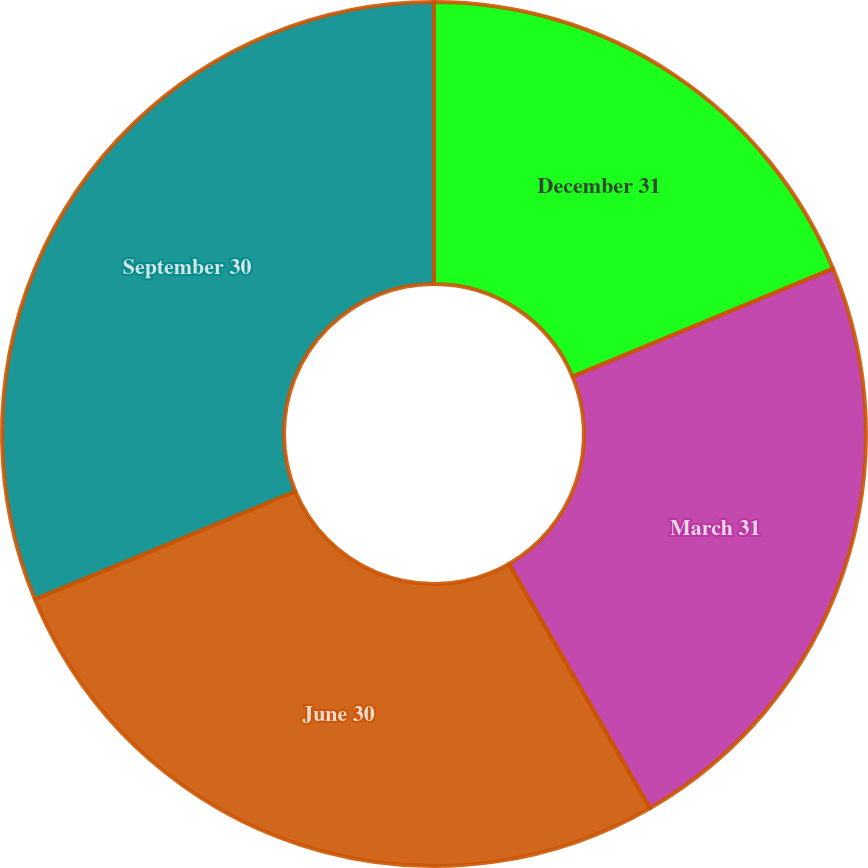<chart> <loc_0><loc_0><loc_500><loc_500><pie_chart><fcel>December 31<fcel>March 31<fcel>June 30<fcel>September 30<nl><fcel>18.75%<fcel>22.92%<fcel>27.08%<fcel>31.25%<nl></chart> 